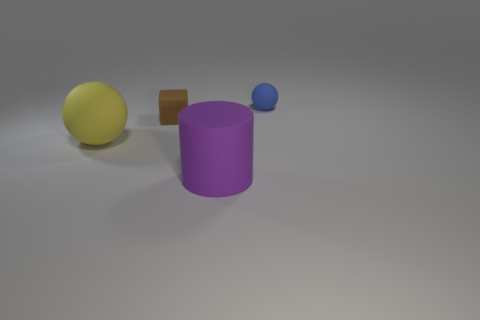How many green things are either balls or rubber cubes?
Make the answer very short. 0. What is the size of the brown cube that is made of the same material as the blue object?
Offer a very short reply. Small. How many big yellow matte objects are the same shape as the tiny brown matte thing?
Provide a succinct answer. 0. Is the number of rubber cylinders that are behind the brown thing greater than the number of purple matte objects that are on the left side of the big purple cylinder?
Make the answer very short. No. Does the large ball have the same color as the ball behind the block?
Your response must be concise. No. There is a cube that is the same size as the blue rubber thing; what material is it?
Offer a terse response. Rubber. What number of objects are tiny blue rubber balls or small objects that are to the left of the tiny blue ball?
Provide a succinct answer. 2. Is the size of the purple thing the same as the matte sphere behind the large yellow ball?
Ensure brevity in your answer.  No. What number of cylinders are yellow rubber things or large blue objects?
Keep it short and to the point. 0. How many things are both left of the big purple matte cylinder and in front of the large rubber sphere?
Your response must be concise. 0. 